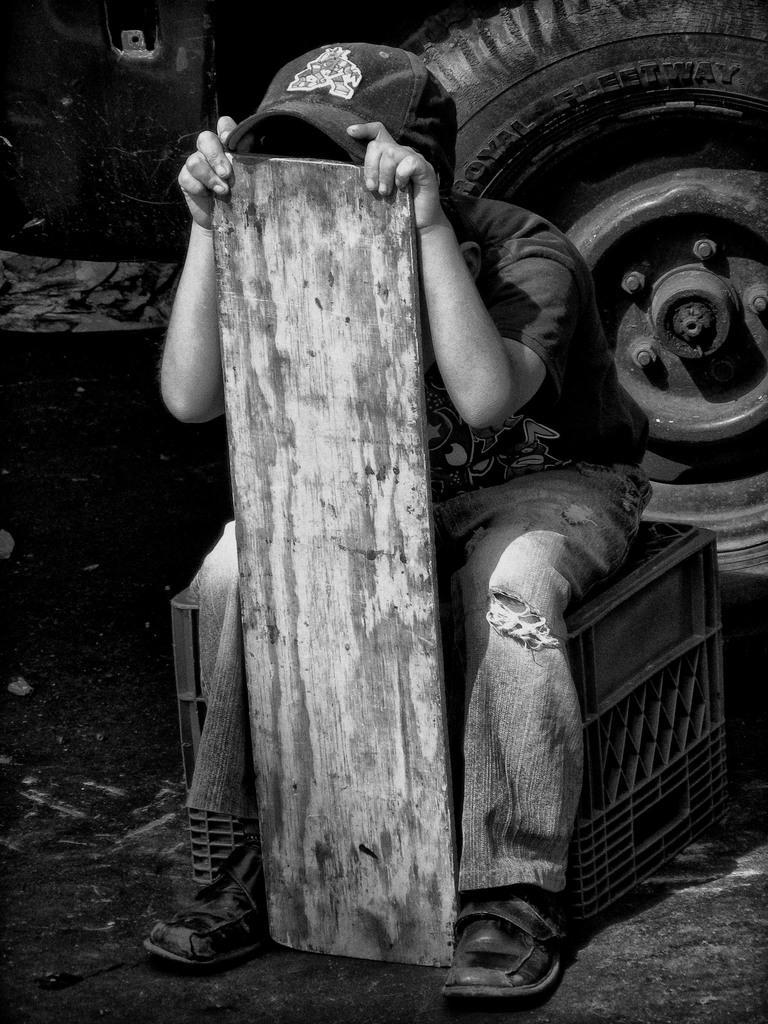Can you describe this image briefly? This is a black and white image. In the image there is a plastic box. On the box there is a boy sitting and kept a cap on his head. And he is holding the wooden object in his hand. Behind him there is a vehicle with tire. 